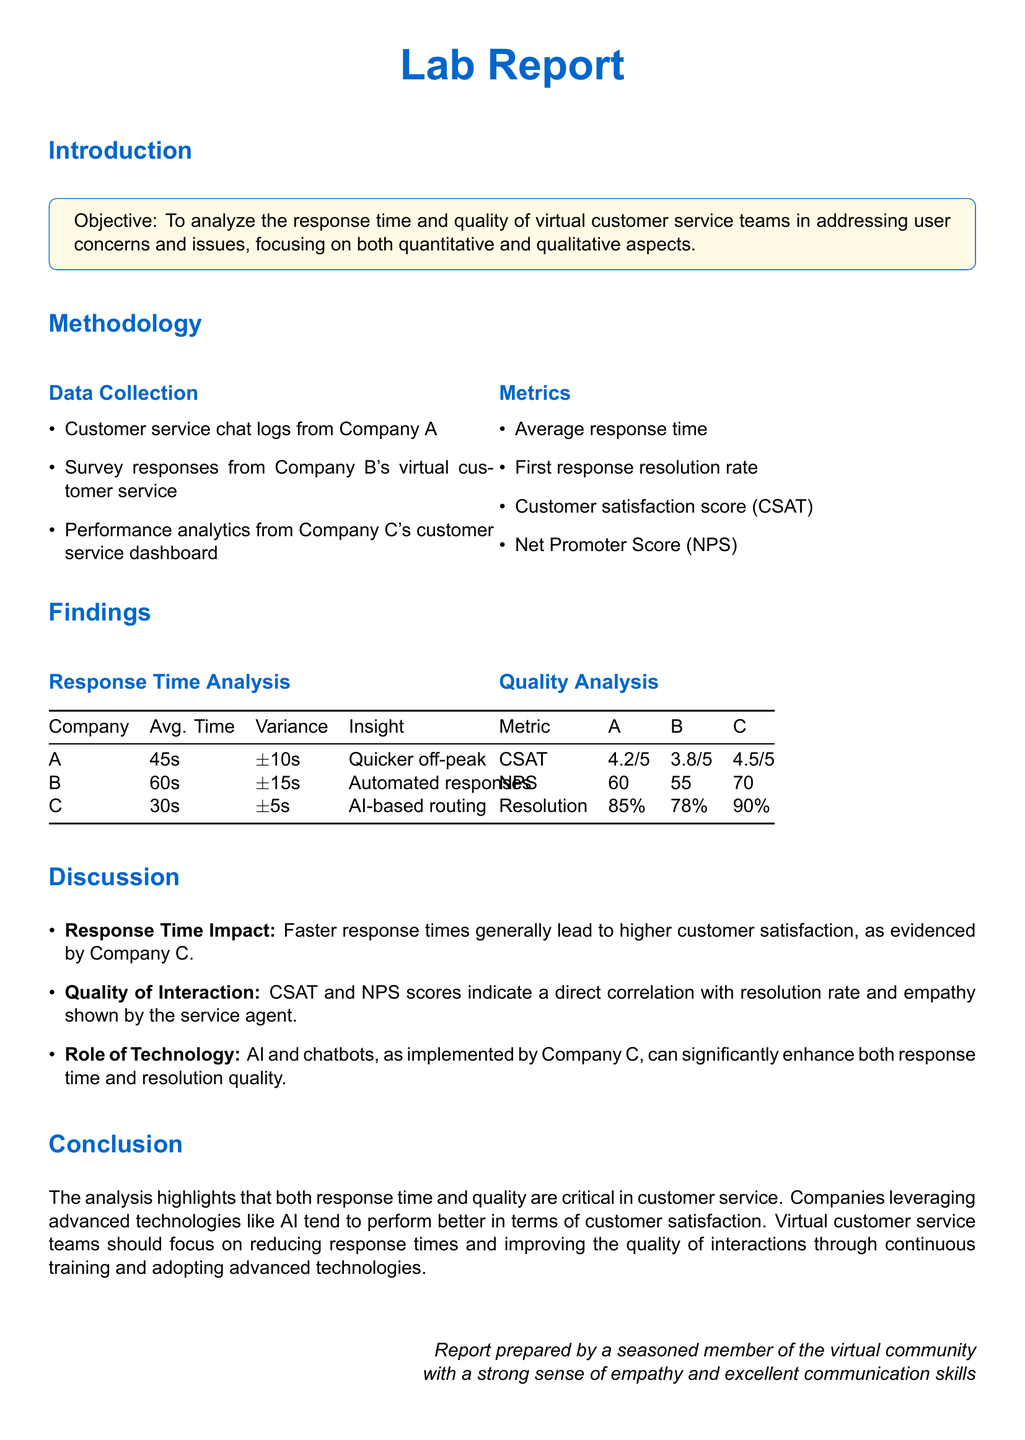What is the objective of the lab report? The objective is stated explicitly in the introduction section of the report.
Answer: To analyze the response time and quality of virtual customer service teams in addressing user concerns and issues Which company has the fastest average response time? The response time analysis table lists the average response times for each company, showing Company C has the fastest time.
Answer: Company C What is the CSAT score for Company B? The quality analysis table presents the customer satisfaction scores for all companies, indicating the score for Company B.
Answer: 3.8/5 What technology does Company C use for improved service? The discussion mentions the role of technology, specifying Company C's use of advanced technologies.
Answer: AI What is the resolution rate for Company A? The quality analysis table provides the resolution rates for each company, revealing the rate for Company A.
Answer: 85% Which company's NPS is 70? The quality analysis table shows the Net Promoter Scores for all companies, identifying the one with an NPS of 70.
Answer: Company C How does response time impact customer satisfaction according to the discussion? The discussion section relates faster response times to higher customer satisfaction, particularly in reference to Company C's performance.
Answer: Higher customer satisfaction What should virtual customer service teams focus on, as stated in the conclusion? The conclusion summarizes recommendations based on the analysis, indicating areas of focus for virtual customer service teams.
Answer: Reducing response times and improving the quality of interactions 